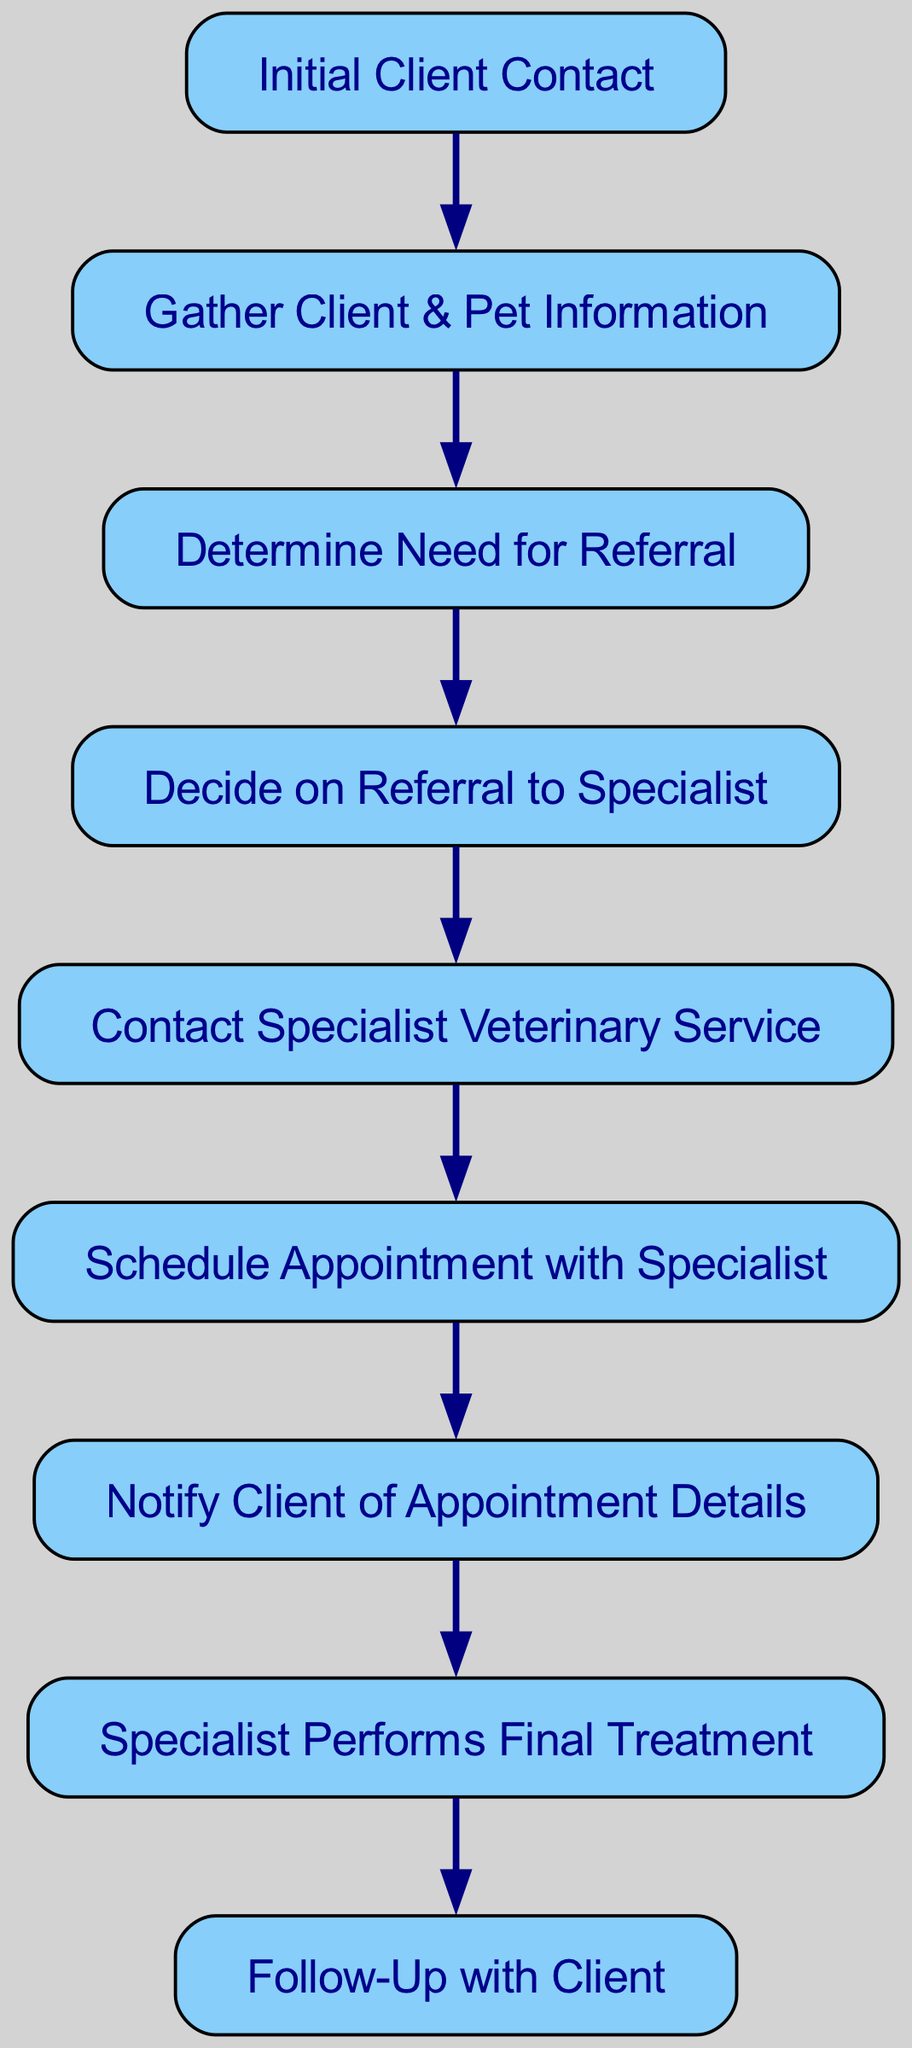What's the first step in the referral process? The first step indicated in the diagram is "Initial Client Contact," which is the starting point of the referral process.
Answer: Initial Client Contact How many total steps are there in the referral process? Counting all the nodes in the diagram, there are 8 distinct steps from the initial contact to the follow-up with the client.
Answer: 8 What follows after "Gather Client & Pet Information"? The diagram shows that after "Gather Client & Pet Information," the next step is "Determine Need for Referral."
Answer: Determine Need for Referral Which step directly precedes "Notify Client of Appointment Details"? The diagram indicates that "Schedule Appointment with Specialist" is the step that directly precedes "Notify Client of Appointment Details."
Answer: Schedule Appointment with Specialist What is the last step in the referral process? The last step in the referral process, according to the diagram, is "Follow-Up with Client." This is where the process concludes after treatment.
Answer: Follow-Up with Client How many connections are there in the graph? The graph consists of 7 directed connections, which represent the flow from one step to the next in the referral process.
Answer: 7 What decision is made after determining the need for a referral? After determining the need for a referral, the diagram indicates that the next decision made is to "Decide on Referral to Specialist."
Answer: Decide on Referral to Specialist Which node has the most outgoing edges? The node "ClientNotification" has the most outgoing edges, leading directly to "Final Treatment."
Answer: ClientNotification What is the relationship between "SpecialistContact" and "FinalTreatment"? "SpecialistContact" leads to "Schedule Appointment," which then proceeds to "ClientNotification," ultimately culminating in "Final Treatment." Therefore, the relationship is a sequential flow from contacting the specialist through to treatment.
Answer: Sequential flow from SpecialistContact to FinalTreatment 